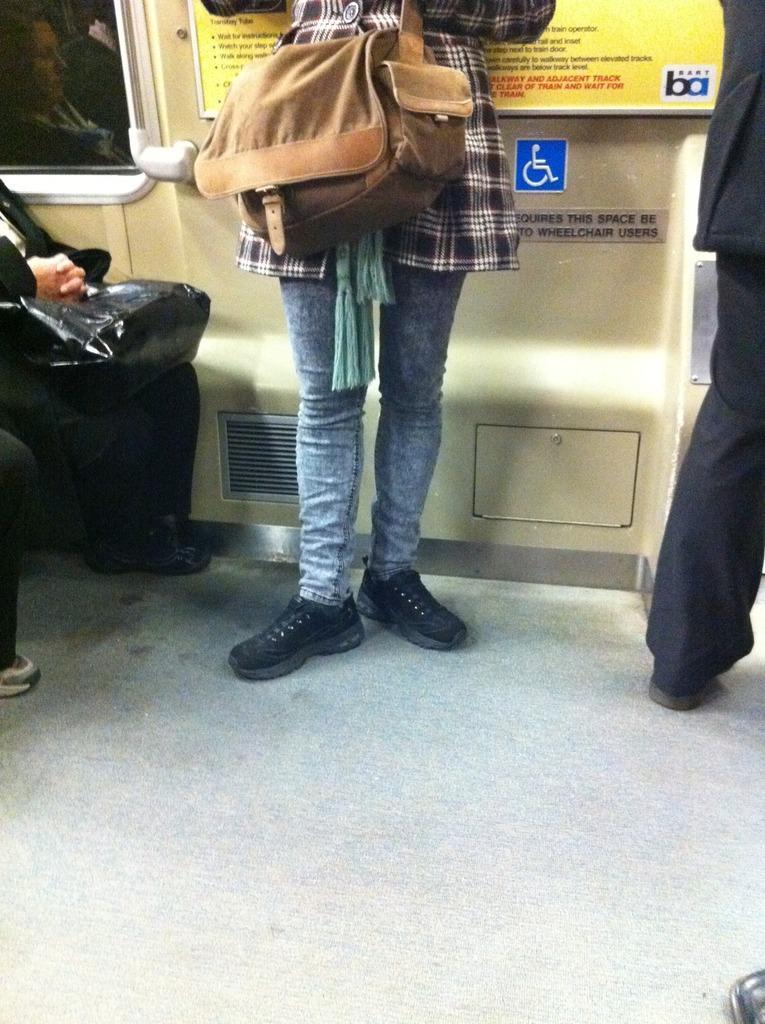Could you give a brief overview of what you see in this image? The women wearing brown bag is standing and there are two people sitting beside her and there is also another person standing another side of her. 